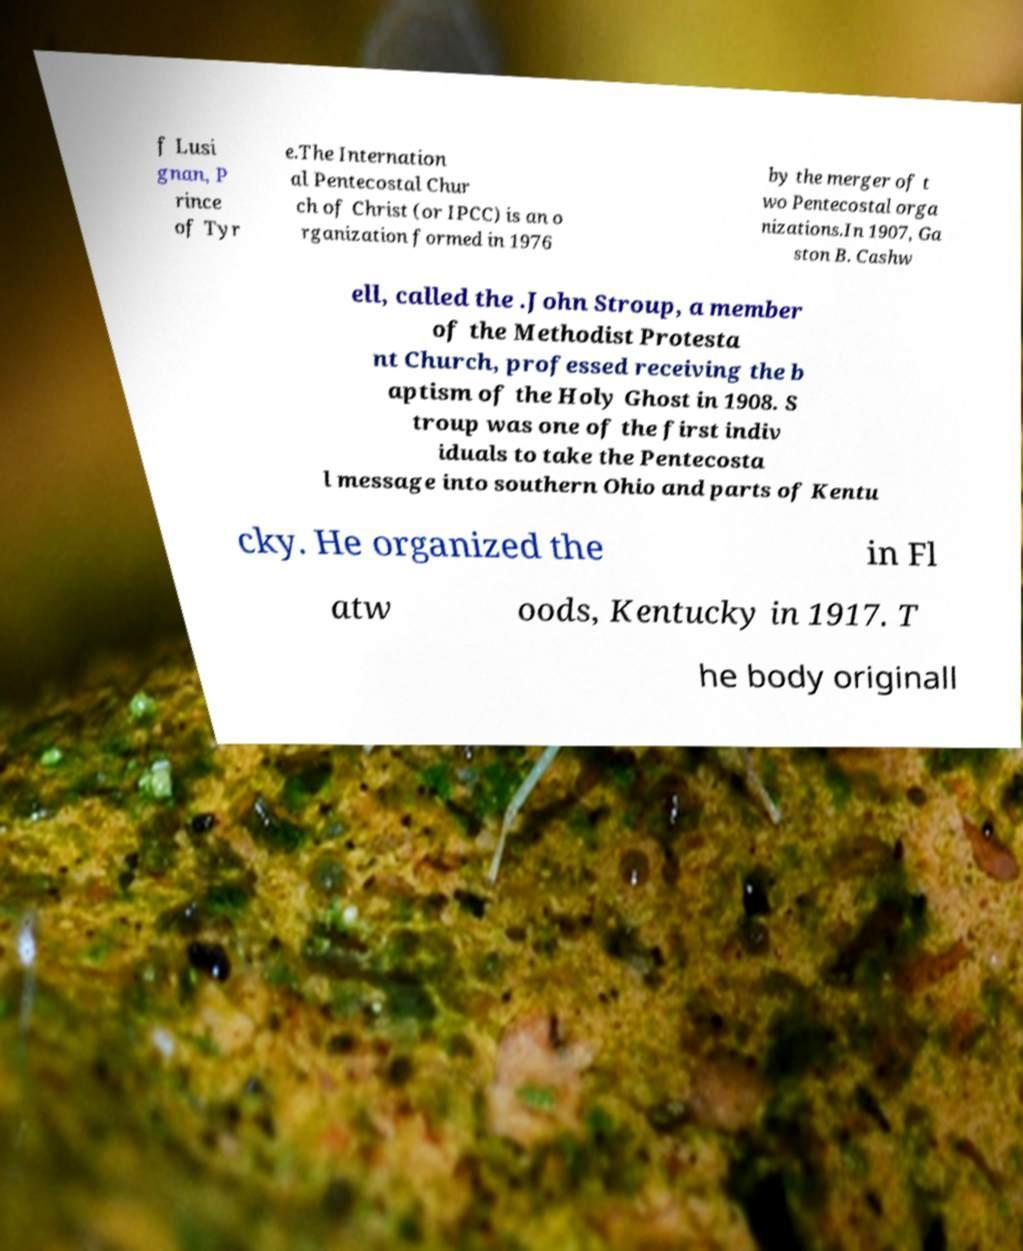Please identify and transcribe the text found in this image. f Lusi gnan, P rince of Tyr e.The Internation al Pentecostal Chur ch of Christ (or IPCC) is an o rganization formed in 1976 by the merger of t wo Pentecostal orga nizations.In 1907, Ga ston B. Cashw ell, called the .John Stroup, a member of the Methodist Protesta nt Church, professed receiving the b aptism of the Holy Ghost in 1908. S troup was one of the first indiv iduals to take the Pentecosta l message into southern Ohio and parts of Kentu cky. He organized the in Fl atw oods, Kentucky in 1917. T he body originall 